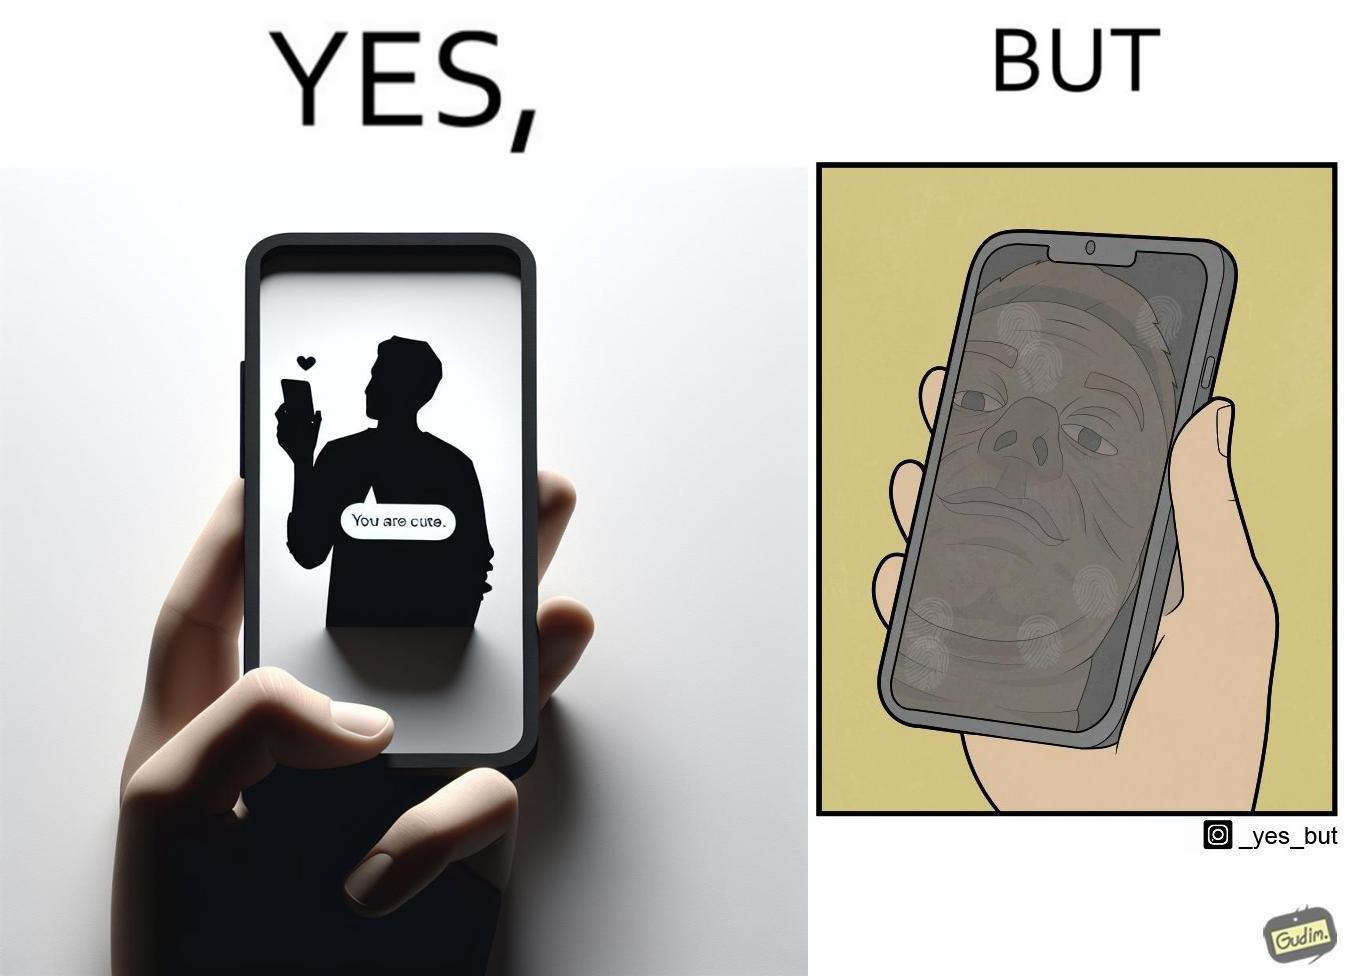What is the satirical meaning behind this image? The image is ironic, because person who received the text saying "you are cute" is apparently not good looking according to the beautyÃÂ standards 